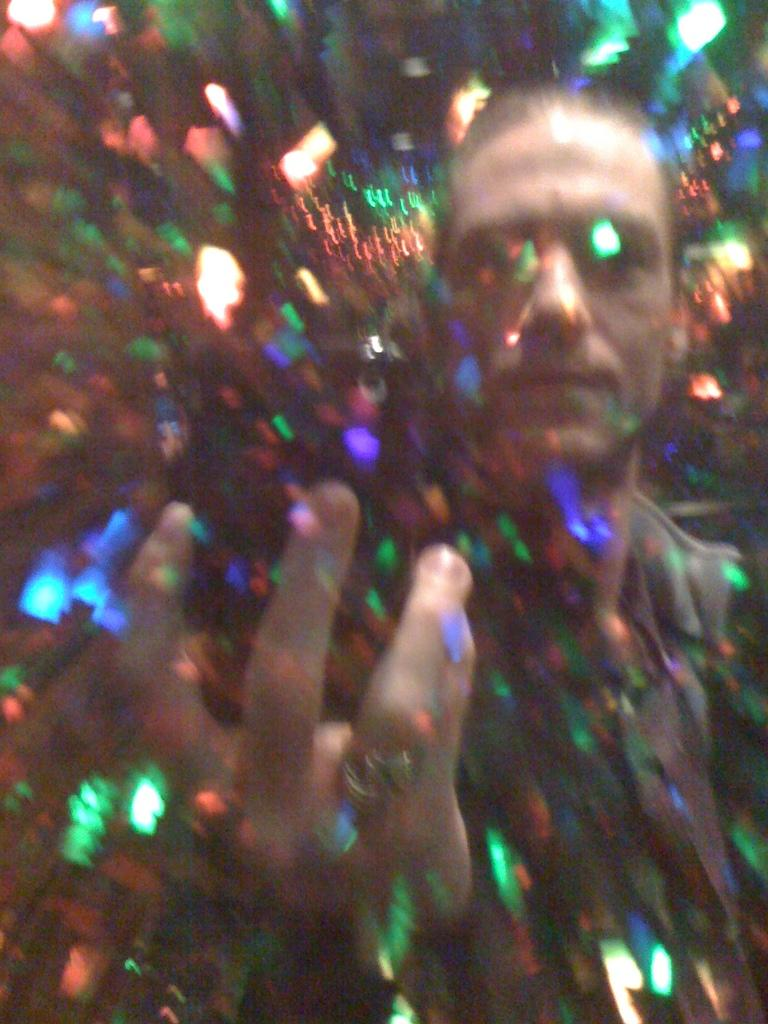Who or what is the main subject in the image? There is a person in the image. What is the person wearing? The person is wearing a black dress. What is the person doing in the image? The person is standing. What can be seen at the front of the image? There are lights at the foreground of the image. How many snakes are crawling on the person's dress in the image? There are no snakes present in the image; the person is wearing a black dress. What type of quarter is visible in the image? There is no quarter present in the image. 